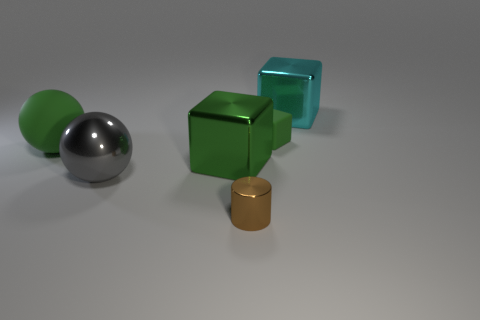How many green blocks must be subtracted to get 1 green blocks? 1 Add 1 big balls. How many objects exist? 7 Add 5 small blue spheres. How many small blue spheres exist? 5 Subtract all green balls. How many balls are left? 1 Subtract all green cubes. How many cubes are left? 1 Subtract 1 cyan blocks. How many objects are left? 5 Subtract all cylinders. How many objects are left? 5 Subtract 1 blocks. How many blocks are left? 2 Subtract all cyan spheres. Subtract all blue cubes. How many spheres are left? 2 Subtract all cyan balls. How many yellow blocks are left? 0 